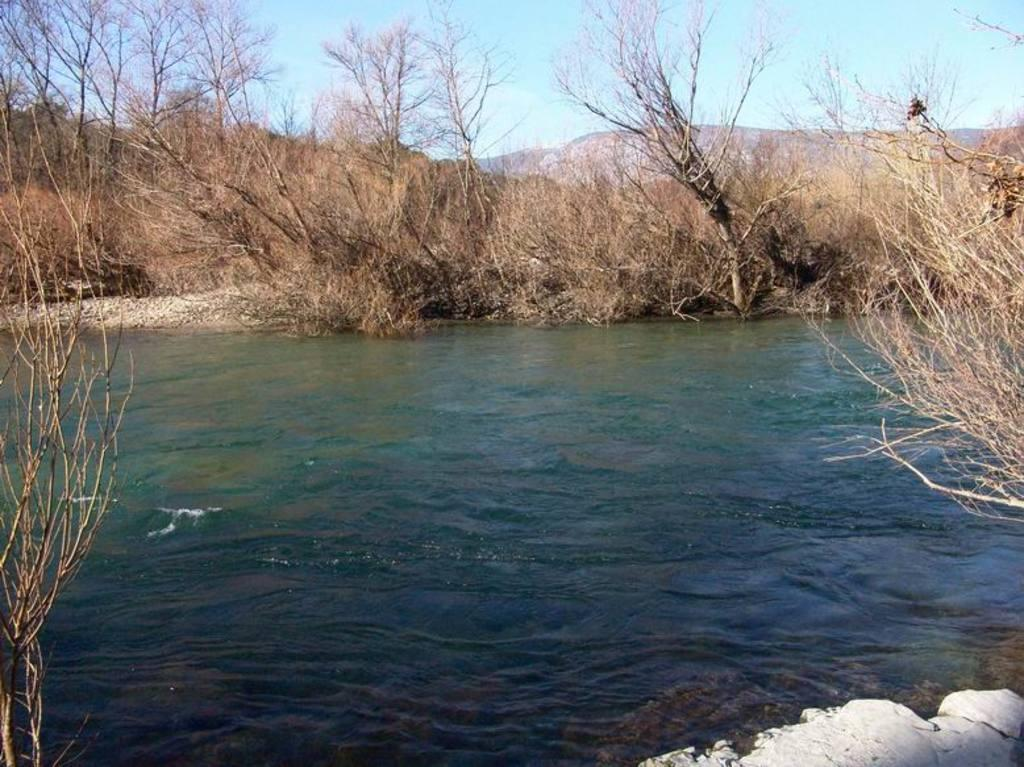What is present at the bottom of the image? There is water and stones at the bottom of the image. What can be seen in the background of the image? There are dry trees in the background of the image. What is visible at the top of the image? The sky is visible at the top of the image. What type of discovery can be seen at the bottom of the image? There is no discovery present in the image; it features water and stones at the bottom. Can you tell me how many feet are visible in the image? There are no feet visible in the image. 